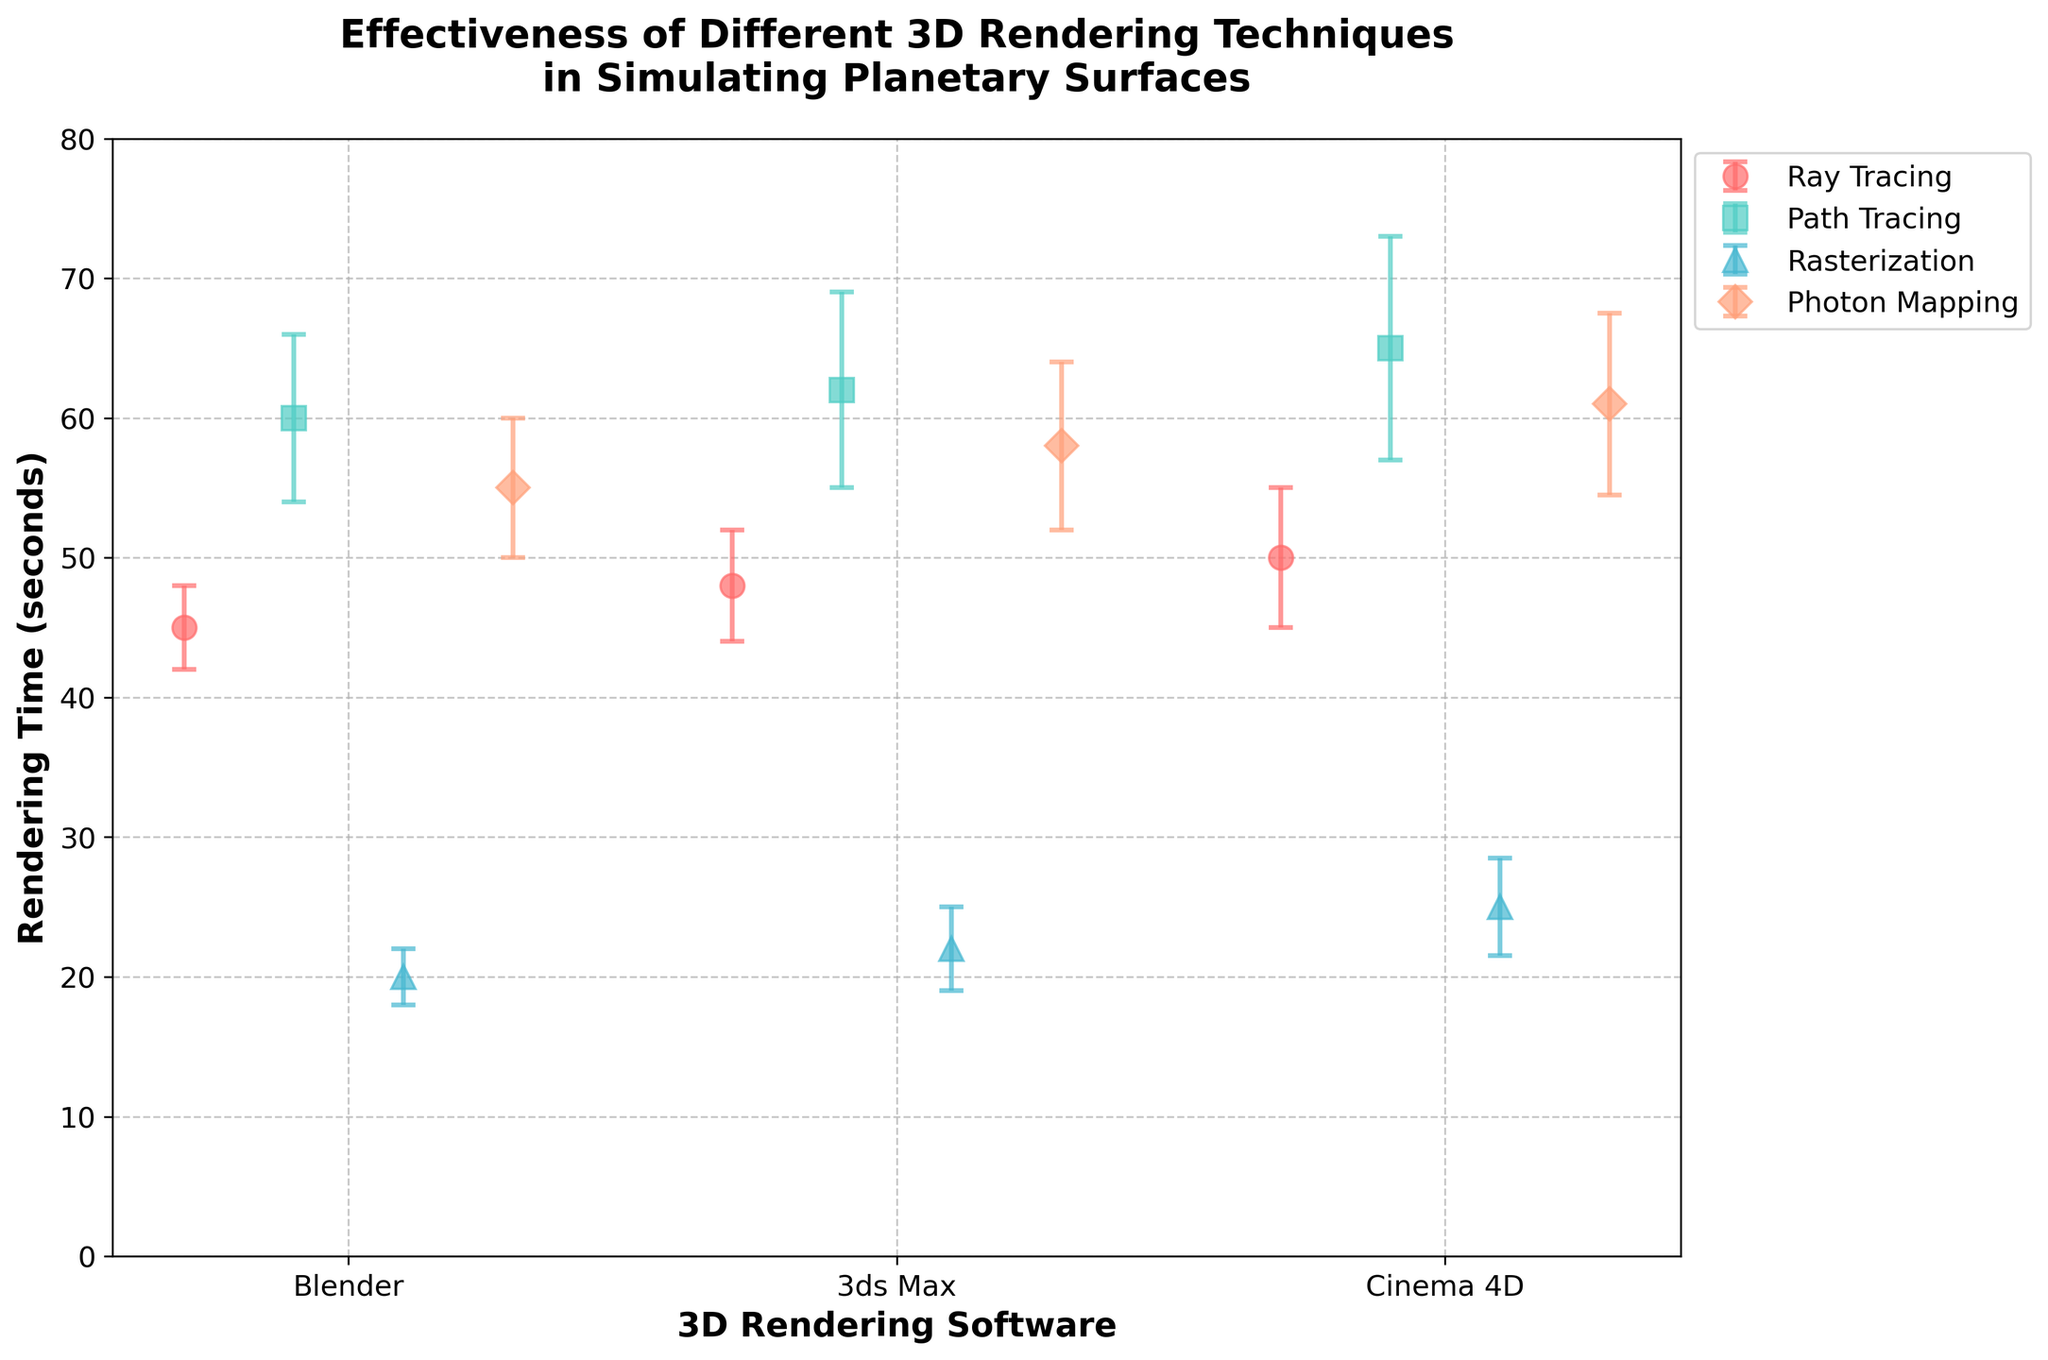Which 3D rendering technique has the shortest average rendering time? By looking at the error bars and the plotted points, it's clear that the technique with the shortest rendering time is Rasterization, as it consistently has the lowest values.
Answer: Rasterization What is the maximum rendering time for Path Tracing using Cinema 4D? Referencing the plotted data points and error bars for Path Tracing using Cinema 4D, we see an upper limit at the high end of the error bar. It reaches 65 + 8 = 73 seconds.
Answer: 73 seconds Which software has the highest variance in rendering time for Ray Tracing? By examining the error bars for Ray Tracing across all software, Cinema 4D has the highest error bar value of 5 seconds, indicating the highest variance for Ray Tracing.
Answer: Cinema 4D How much longer does it take, on average, to render using Photon Mapping in Blender compared to Rasterization in the same software? The average rendering time for Photon Mapping in Blender is 55 seconds and for Rasterization in Blender is 20 seconds. The difference is 55 - 20 = 35 seconds.
Answer: 35 seconds Compare the rendering times for 3ds Max software between Path Tracing and Rasterization. Which one is faster, and by how much? For 3ds Max, Path Tracing has a rendering time of 62 seconds, while Rasterization has 22 seconds. Rasterization is faster by 62 - 22 = 40 seconds.
Answer: Rasterization by 40 seconds What is the average rendering time across all techniques for Blender? For Blender: Ray Tracing (45), Path Tracing (60), Rasterization (20), and Photon Mapping (55). Sum them up: 45 + 60 + 20 + 55 = 180. Average is 180 / 4 = 45 seconds.
Answer: 45 seconds Which technique shows the largest range of rendering times across all software? Looking at the error bars' span for each technique, Path Tracing shows the highest rendering times across all software, from 60 to a maximum of 65 + 8 = 73, giving a range from 60 to 73.
Answer: Path Tracing For which technique is the variance in rendering time most consistent across all software? Comparing the heights of the error bars (variance), Ray Tracing shows the smallest fluctuations in error bar heights across all three software: 3, 4, and 5 seconds, relatively consistent.
Answer: Ray Tracing 